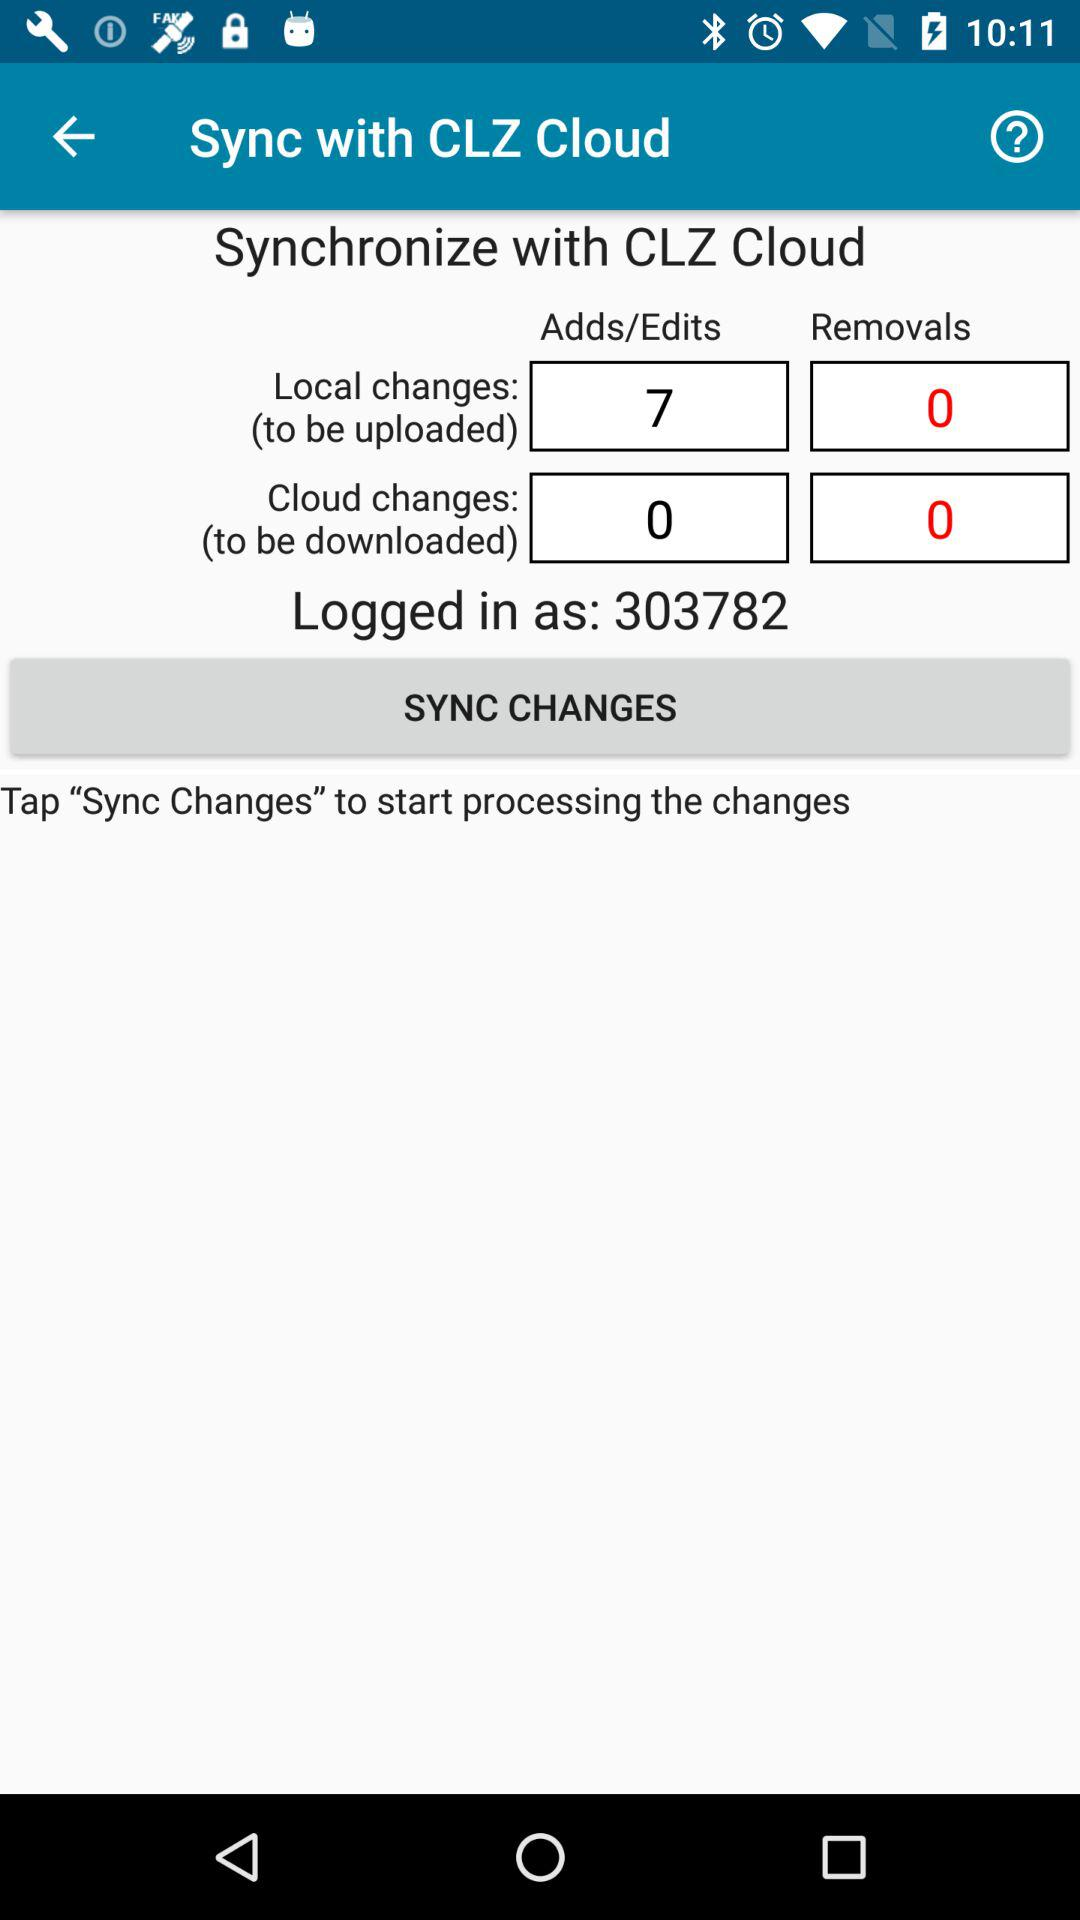What is the count for the adds/edits in "Local changes"? The count is 7. 